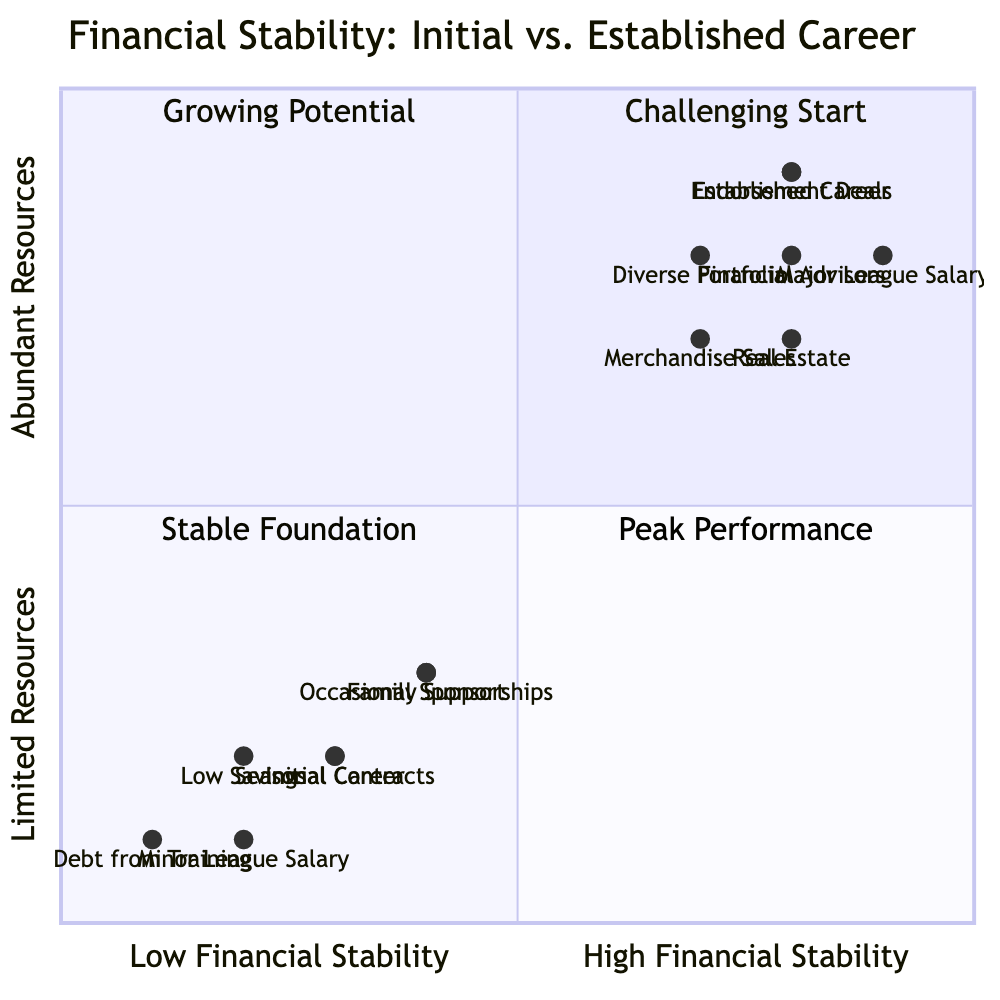What quadrant does the "Initial Career" fall into? The "Initial Career" is positioned at [0.3, 0.2], which places it in the lower-left region of the quadrant chart. This region is labeled "Challenging Start."
Answer: Challenging Start How many total income sources are listed for the "Established Career"? The "Established Career" has three income sources: "Major League Salary," "Endorsement Deals," and "Merchandise Sales."
Answer: 3 What is the financial challenge associated with an "Initial Career"? One of the listed financial challenges for "Initial Career" is "Debt from Training Expenses," which is placed at [0.1, 0.1].
Answer: Debt from Training Expenses In which quadrant is "Endorsement Deals" located? "Endorsement Deals" is positioned at [0.8, 0.9], which puts it in the upper-right region of the quadrant chart labeled "Peak Performance."
Answer: Peak Performance What is the support system type available during the "Initial Career"? The support systems listed for the "Initial Career" are "Family Support," "Local Community Fundraising," and "Small Endorsements." A common option is "Family Support."
Answer: Family Support What defines the difference in income sources between the "Initial Career" and "Established Career"? The "Initial Career" relies on sources like "Minor League Salary" and occasional sponsorships, while the "Established Career" has major income sources such as "Major League Salary" and endorsement deals, highlighting a significant increase in income potential from initial to established stages.
Answer: Major League Salary What investment option is not available in the "Initial Career"? The "Initial Career" mainly has "Minimal Investments" and "Relying on Basic Savings Accounts," while "Real Estate" is an investment option not available in "Initial Career."
Answer: Real Estate How does the financial stability change from "Initial Career" to "Established Career"? The transition from "Initial Career" at [0.3, 0.2] to "Established Career" at [0.8, 0.9] shows a significant increase in both financial stability and resource abundance throughout the career.
Answer: Increase What is the primary financial challenge for an "Established Career"? A primary financial challenge for "Established Career" is "Investment Management," which requires careful handling of more complex financial situations due to increased income levels.
Answer: Investment Management 